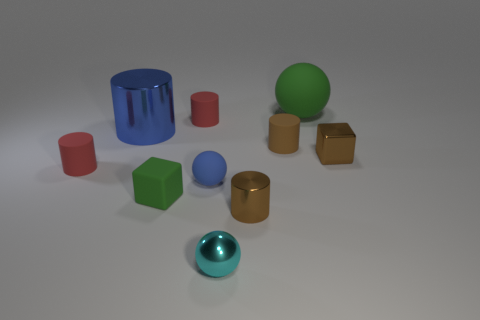Do the metal cube and the tiny metallic cylinder have the same color?
Make the answer very short. Yes. What is the size of the brown cylinder that is the same material as the tiny green cube?
Provide a succinct answer. Small. Is there anything else of the same color as the large rubber object?
Ensure brevity in your answer.  Yes. Does the matte sphere to the right of the tiny brown rubber cylinder have the same color as the small cube that is on the left side of the small brown metallic block?
Provide a short and direct response. Yes. There is a cube that is to the left of the metal sphere; is it the same size as the big blue metallic object?
Provide a succinct answer. No. There is a metallic object that is the same color as the tiny metallic cylinder; what shape is it?
Provide a short and direct response. Cube. What number of gray objects are either shiny cubes or large shiny cylinders?
Ensure brevity in your answer.  0. Are there fewer small cyan metal spheres that are on the left side of the large shiny thing than shiny objects that are in front of the brown metal block?
Give a very brief answer. Yes. There is a cyan metal sphere; is it the same size as the brown cylinder on the right side of the small brown metal cylinder?
Make the answer very short. Yes. What number of matte cubes are the same size as the metallic cube?
Keep it short and to the point. 1. 